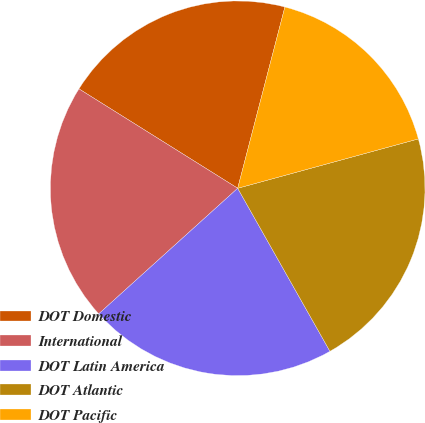Convert chart. <chart><loc_0><loc_0><loc_500><loc_500><pie_chart><fcel>DOT Domestic<fcel>International<fcel>DOT Latin America<fcel>DOT Atlantic<fcel>DOT Pacific<nl><fcel>20.15%<fcel>20.6%<fcel>21.5%<fcel>21.05%<fcel>16.7%<nl></chart> 